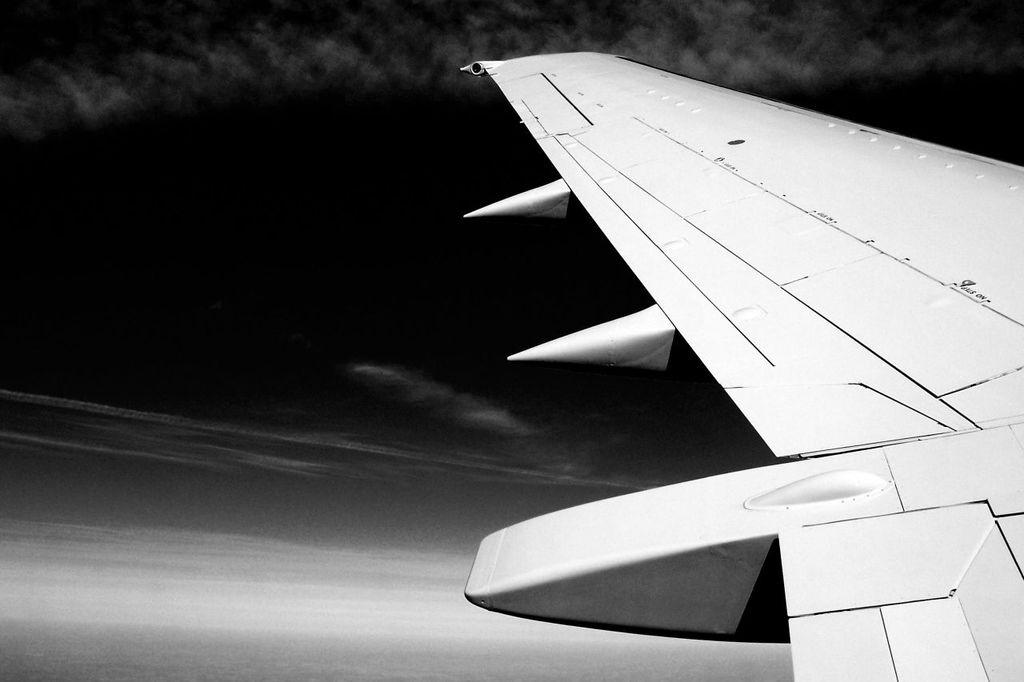What is the color scheme of the image? The image is black and white. What is the main subject of the image? There is an airplane in the image. What is the airplane doing in the image? The airplane is flying in the air. What can be seen in the background of the image? The sky is visible in the background of the image. What is present in the sky? Clouds are present in the sky. What type of paint is being used to create the popcorn effect on the airplane in the image? There is no popcorn effect or paint present on the airplane in the image; it is a black and white photograph of an airplane flying in the sky. 